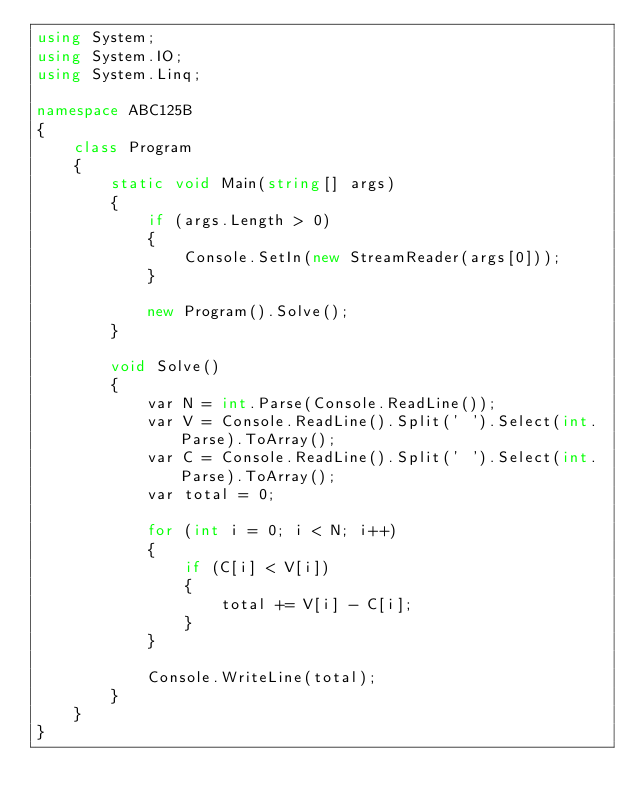<code> <loc_0><loc_0><loc_500><loc_500><_C#_>using System;
using System.IO;
using System.Linq;

namespace ABC125B
{
    class Program
    {
        static void Main(string[] args)
        {
            if (args.Length > 0)
            {
                Console.SetIn(new StreamReader(args[0]));
            }

            new Program().Solve();
        }

        void Solve()
        {
            var N = int.Parse(Console.ReadLine());
            var V = Console.ReadLine().Split(' ').Select(int.Parse).ToArray();
            var C = Console.ReadLine().Split(' ').Select(int.Parse).ToArray();
            var total = 0;

            for (int i = 0; i < N; i++)
            {
                if (C[i] < V[i])
                {
                    total += V[i] - C[i];
                }
            }

            Console.WriteLine(total);
        }
    }
}
</code> 